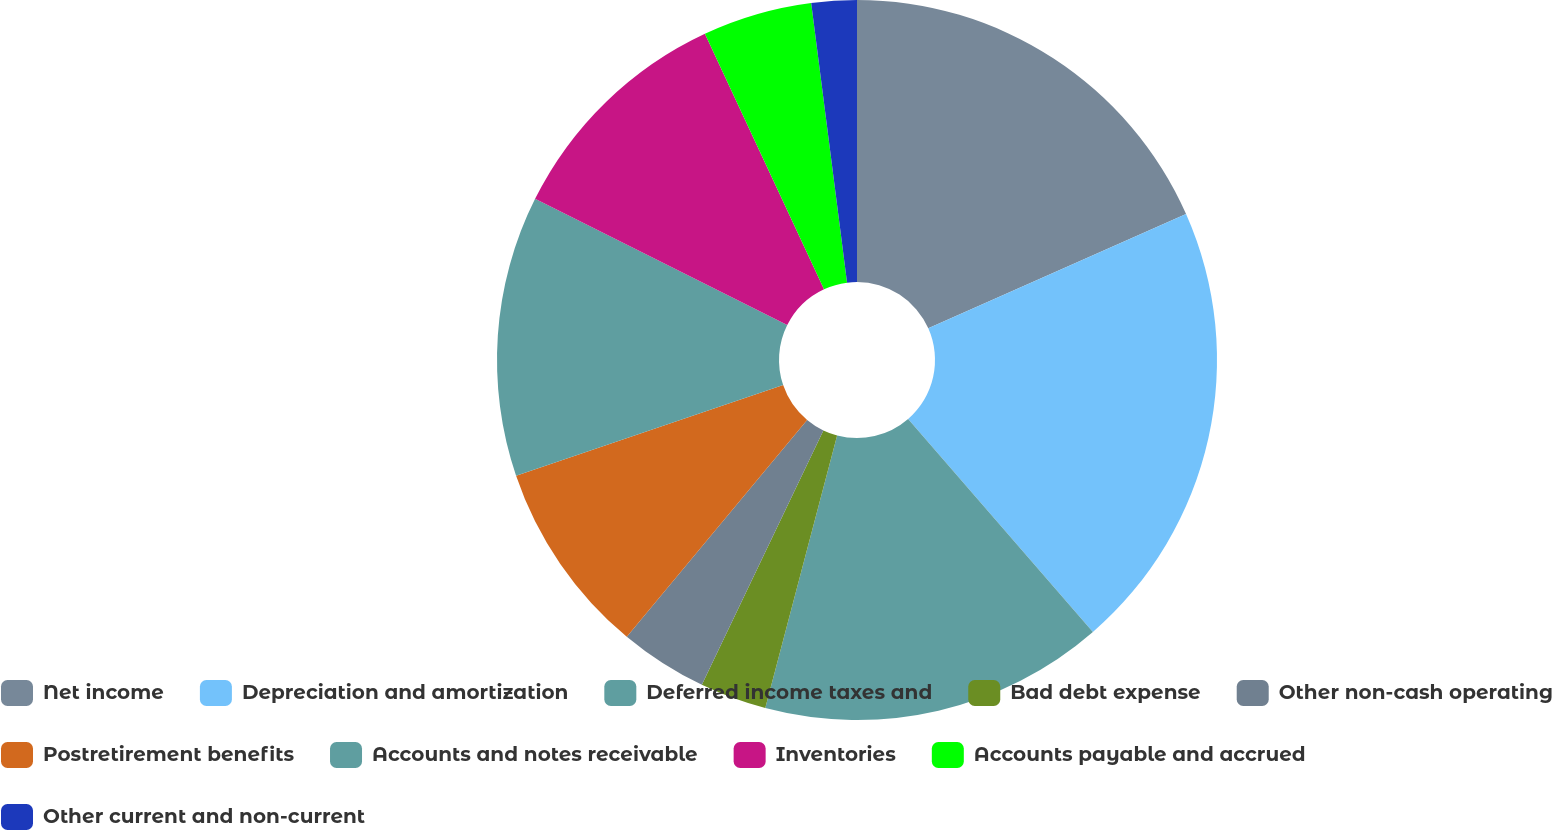<chart> <loc_0><loc_0><loc_500><loc_500><pie_chart><fcel>Net income<fcel>Depreciation and amortization<fcel>Deferred income taxes and<fcel>Bad debt expense<fcel>Other non-cash operating<fcel>Postretirement benefits<fcel>Accounts and notes receivable<fcel>Inventories<fcel>Accounts payable and accrued<fcel>Other current and non-current<nl><fcel>18.35%<fcel>20.27%<fcel>15.47%<fcel>2.99%<fcel>3.95%<fcel>8.75%<fcel>12.59%<fcel>10.67%<fcel>4.91%<fcel>2.03%<nl></chart> 